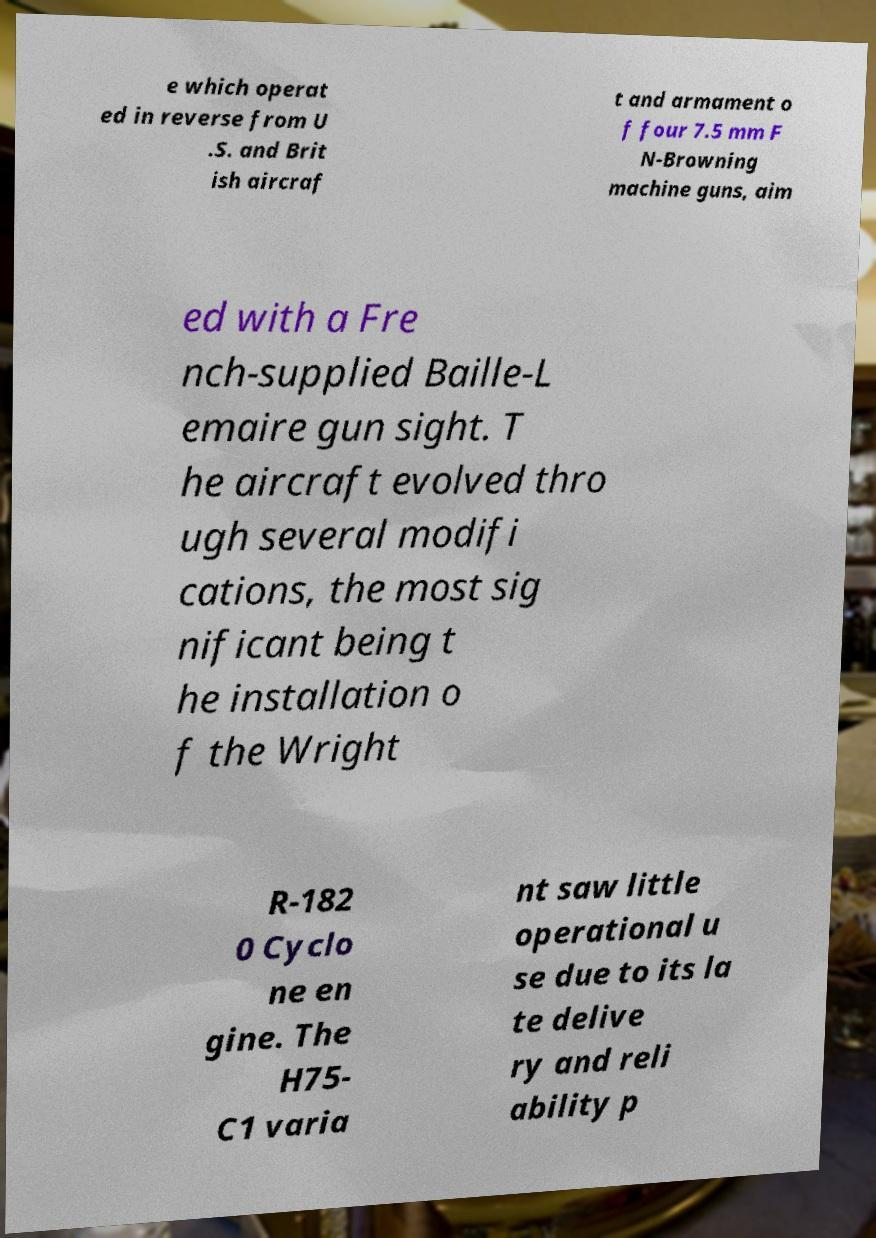Can you read and provide the text displayed in the image?This photo seems to have some interesting text. Can you extract and type it out for me? e which operat ed in reverse from U .S. and Brit ish aircraf t and armament o f four 7.5 mm F N-Browning machine guns, aim ed with a Fre nch-supplied Baille-L emaire gun sight. T he aircraft evolved thro ugh several modifi cations, the most sig nificant being t he installation o f the Wright R-182 0 Cyclo ne en gine. The H75- C1 varia nt saw little operational u se due to its la te delive ry and reli ability p 